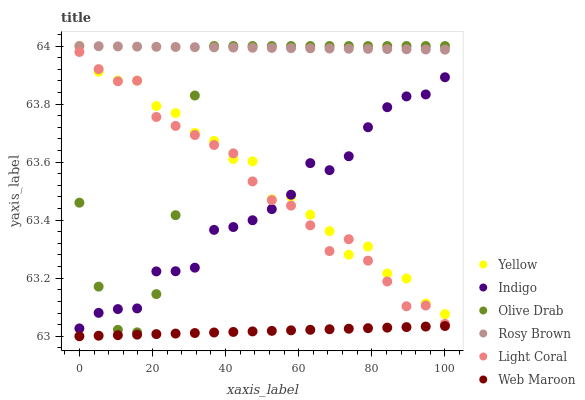Does Web Maroon have the minimum area under the curve?
Answer yes or no. Yes. Does Rosy Brown have the maximum area under the curve?
Answer yes or no. Yes. Does Rosy Brown have the minimum area under the curve?
Answer yes or no. No. Does Web Maroon have the maximum area under the curve?
Answer yes or no. No. Is Web Maroon the smoothest?
Answer yes or no. Yes. Is Yellow the roughest?
Answer yes or no. Yes. Is Rosy Brown the smoothest?
Answer yes or no. No. Is Rosy Brown the roughest?
Answer yes or no. No. Does Web Maroon have the lowest value?
Answer yes or no. Yes. Does Rosy Brown have the lowest value?
Answer yes or no. No. Does Olive Drab have the highest value?
Answer yes or no. Yes. Does Web Maroon have the highest value?
Answer yes or no. No. Is Web Maroon less than Olive Drab?
Answer yes or no. Yes. Is Olive Drab greater than Web Maroon?
Answer yes or no. Yes. Does Olive Drab intersect Rosy Brown?
Answer yes or no. Yes. Is Olive Drab less than Rosy Brown?
Answer yes or no. No. Is Olive Drab greater than Rosy Brown?
Answer yes or no. No. Does Web Maroon intersect Olive Drab?
Answer yes or no. No. 